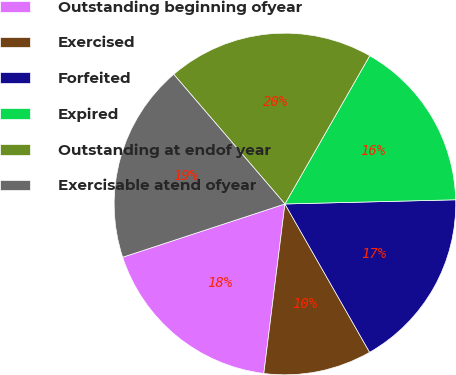<chart> <loc_0><loc_0><loc_500><loc_500><pie_chart><fcel>Outstanding beginning ofyear<fcel>Exercised<fcel>Forfeited<fcel>Expired<fcel>Outstanding at endof year<fcel>Exercisable atend ofyear<nl><fcel>17.98%<fcel>10.23%<fcel>17.13%<fcel>16.34%<fcel>19.55%<fcel>18.76%<nl></chart> 